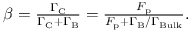<formula> <loc_0><loc_0><loc_500><loc_500>\begin{array} { r } { \beta = \frac { \Gamma _ { C } } { \Gamma _ { C } + \Gamma _ { B } } = \frac { F _ { p } } { F _ { p } + \Gamma _ { B } / \Gamma _ { B u l k } } . } \end{array}</formula> 